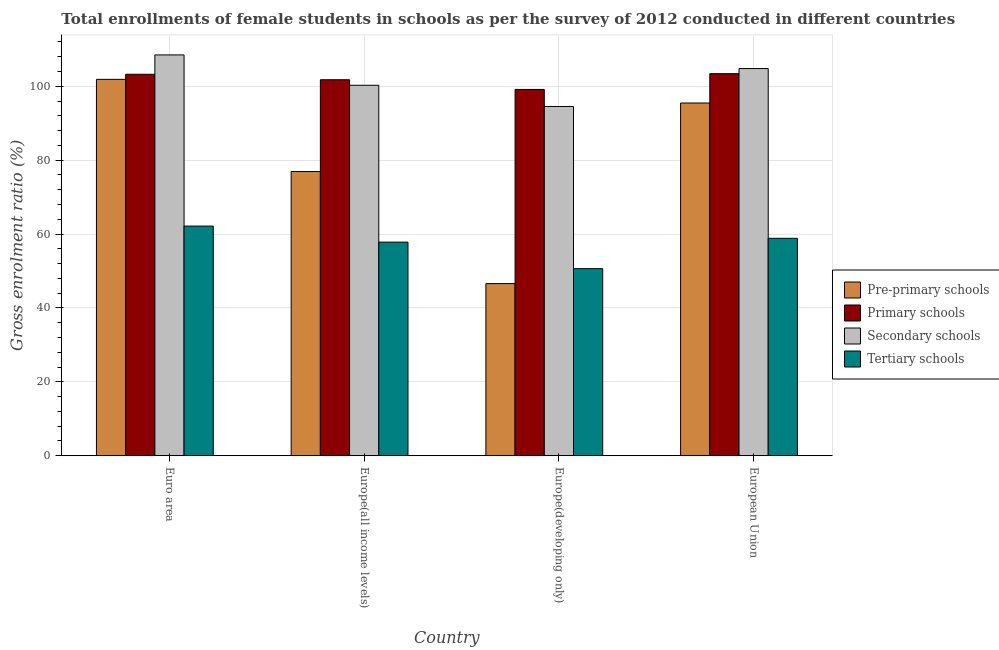Are the number of bars per tick equal to the number of legend labels?
Make the answer very short. Yes. How many bars are there on the 3rd tick from the left?
Ensure brevity in your answer.  4. What is the label of the 2nd group of bars from the left?
Offer a very short reply. Europe(all income levels). In how many cases, is the number of bars for a given country not equal to the number of legend labels?
Give a very brief answer. 0. What is the gross enrolment ratio(female) in primary schools in Europe(all income levels)?
Your response must be concise. 101.75. Across all countries, what is the maximum gross enrolment ratio(female) in pre-primary schools?
Give a very brief answer. 101.86. Across all countries, what is the minimum gross enrolment ratio(female) in tertiary schools?
Your answer should be compact. 50.63. In which country was the gross enrolment ratio(female) in primary schools maximum?
Your answer should be compact. European Union. In which country was the gross enrolment ratio(female) in pre-primary schools minimum?
Your answer should be very brief. Europe(developing only). What is the total gross enrolment ratio(female) in secondary schools in the graph?
Offer a very short reply. 408.02. What is the difference between the gross enrolment ratio(female) in primary schools in Euro area and that in Europe(developing only)?
Provide a succinct answer. 4.11. What is the difference between the gross enrolment ratio(female) in primary schools in Euro area and the gross enrolment ratio(female) in secondary schools in Europe(all income levels)?
Keep it short and to the point. 2.98. What is the average gross enrolment ratio(female) in secondary schools per country?
Provide a succinct answer. 102.01. What is the difference between the gross enrolment ratio(female) in tertiary schools and gross enrolment ratio(female) in pre-primary schools in Euro area?
Provide a succinct answer. -39.71. In how many countries, is the gross enrolment ratio(female) in tertiary schools greater than 84 %?
Give a very brief answer. 0. What is the ratio of the gross enrolment ratio(female) in secondary schools in Europe(all income levels) to that in European Union?
Provide a short and direct response. 0.96. Is the gross enrolment ratio(female) in pre-primary schools in Europe(developing only) less than that in European Union?
Offer a very short reply. Yes. What is the difference between the highest and the second highest gross enrolment ratio(female) in secondary schools?
Provide a succinct answer. 3.69. What is the difference between the highest and the lowest gross enrolment ratio(female) in primary schools?
Your answer should be compact. 4.27. In how many countries, is the gross enrolment ratio(female) in secondary schools greater than the average gross enrolment ratio(female) in secondary schools taken over all countries?
Keep it short and to the point. 2. Is it the case that in every country, the sum of the gross enrolment ratio(female) in tertiary schools and gross enrolment ratio(female) in secondary schools is greater than the sum of gross enrolment ratio(female) in primary schools and gross enrolment ratio(female) in pre-primary schools?
Give a very brief answer. Yes. What does the 3rd bar from the left in Euro area represents?
Keep it short and to the point. Secondary schools. What does the 4th bar from the right in Europe(developing only) represents?
Give a very brief answer. Pre-primary schools. Are all the bars in the graph horizontal?
Your answer should be compact. No. What is the difference between two consecutive major ticks on the Y-axis?
Your answer should be very brief. 20. Does the graph contain any zero values?
Provide a short and direct response. No. How are the legend labels stacked?
Provide a short and direct response. Vertical. What is the title of the graph?
Your response must be concise. Total enrollments of female students in schools as per the survey of 2012 conducted in different countries. What is the label or title of the Y-axis?
Your answer should be compact. Gross enrolment ratio (%). What is the Gross enrolment ratio (%) in Pre-primary schools in Euro area?
Your response must be concise. 101.86. What is the Gross enrolment ratio (%) of Primary schools in Euro area?
Your answer should be compact. 103.23. What is the Gross enrolment ratio (%) in Secondary schools in Euro area?
Provide a short and direct response. 108.47. What is the Gross enrolment ratio (%) in Tertiary schools in Euro area?
Make the answer very short. 62.15. What is the Gross enrolment ratio (%) of Pre-primary schools in Europe(all income levels)?
Keep it short and to the point. 76.91. What is the Gross enrolment ratio (%) of Primary schools in Europe(all income levels)?
Your response must be concise. 101.75. What is the Gross enrolment ratio (%) in Secondary schools in Europe(all income levels)?
Your answer should be very brief. 100.25. What is the Gross enrolment ratio (%) in Tertiary schools in Europe(all income levels)?
Provide a short and direct response. 57.81. What is the Gross enrolment ratio (%) in Pre-primary schools in Europe(developing only)?
Offer a terse response. 46.59. What is the Gross enrolment ratio (%) in Primary schools in Europe(developing only)?
Your answer should be compact. 99.13. What is the Gross enrolment ratio (%) in Secondary schools in Europe(developing only)?
Keep it short and to the point. 94.52. What is the Gross enrolment ratio (%) in Tertiary schools in Europe(developing only)?
Keep it short and to the point. 50.63. What is the Gross enrolment ratio (%) in Pre-primary schools in European Union?
Keep it short and to the point. 95.46. What is the Gross enrolment ratio (%) in Primary schools in European Union?
Your answer should be compact. 103.4. What is the Gross enrolment ratio (%) in Secondary schools in European Union?
Your answer should be very brief. 104.78. What is the Gross enrolment ratio (%) of Tertiary schools in European Union?
Give a very brief answer. 58.84. Across all countries, what is the maximum Gross enrolment ratio (%) in Pre-primary schools?
Your response must be concise. 101.86. Across all countries, what is the maximum Gross enrolment ratio (%) in Primary schools?
Provide a short and direct response. 103.4. Across all countries, what is the maximum Gross enrolment ratio (%) in Secondary schools?
Ensure brevity in your answer.  108.47. Across all countries, what is the maximum Gross enrolment ratio (%) in Tertiary schools?
Give a very brief answer. 62.15. Across all countries, what is the minimum Gross enrolment ratio (%) in Pre-primary schools?
Ensure brevity in your answer.  46.59. Across all countries, what is the minimum Gross enrolment ratio (%) in Primary schools?
Offer a terse response. 99.13. Across all countries, what is the minimum Gross enrolment ratio (%) in Secondary schools?
Your response must be concise. 94.52. Across all countries, what is the minimum Gross enrolment ratio (%) of Tertiary schools?
Keep it short and to the point. 50.63. What is the total Gross enrolment ratio (%) of Pre-primary schools in the graph?
Your answer should be very brief. 320.82. What is the total Gross enrolment ratio (%) of Primary schools in the graph?
Offer a very short reply. 407.51. What is the total Gross enrolment ratio (%) in Secondary schools in the graph?
Your response must be concise. 408.02. What is the total Gross enrolment ratio (%) of Tertiary schools in the graph?
Give a very brief answer. 229.43. What is the difference between the Gross enrolment ratio (%) in Pre-primary schools in Euro area and that in Europe(all income levels)?
Provide a succinct answer. 24.95. What is the difference between the Gross enrolment ratio (%) of Primary schools in Euro area and that in Europe(all income levels)?
Your answer should be very brief. 1.48. What is the difference between the Gross enrolment ratio (%) in Secondary schools in Euro area and that in Europe(all income levels)?
Provide a short and direct response. 8.22. What is the difference between the Gross enrolment ratio (%) of Tertiary schools in Euro area and that in Europe(all income levels)?
Make the answer very short. 4.34. What is the difference between the Gross enrolment ratio (%) of Pre-primary schools in Euro area and that in Europe(developing only)?
Keep it short and to the point. 55.28. What is the difference between the Gross enrolment ratio (%) in Primary schools in Euro area and that in Europe(developing only)?
Offer a very short reply. 4.11. What is the difference between the Gross enrolment ratio (%) in Secondary schools in Euro area and that in Europe(developing only)?
Your response must be concise. 13.96. What is the difference between the Gross enrolment ratio (%) of Tertiary schools in Euro area and that in Europe(developing only)?
Offer a terse response. 11.52. What is the difference between the Gross enrolment ratio (%) in Pre-primary schools in Euro area and that in European Union?
Your answer should be very brief. 6.4. What is the difference between the Gross enrolment ratio (%) of Primary schools in Euro area and that in European Union?
Your answer should be compact. -0.16. What is the difference between the Gross enrolment ratio (%) of Secondary schools in Euro area and that in European Union?
Make the answer very short. 3.69. What is the difference between the Gross enrolment ratio (%) in Tertiary schools in Euro area and that in European Union?
Ensure brevity in your answer.  3.31. What is the difference between the Gross enrolment ratio (%) in Pre-primary schools in Europe(all income levels) and that in Europe(developing only)?
Make the answer very short. 30.33. What is the difference between the Gross enrolment ratio (%) in Primary schools in Europe(all income levels) and that in Europe(developing only)?
Offer a very short reply. 2.62. What is the difference between the Gross enrolment ratio (%) in Secondary schools in Europe(all income levels) and that in Europe(developing only)?
Provide a short and direct response. 5.74. What is the difference between the Gross enrolment ratio (%) in Tertiary schools in Europe(all income levels) and that in Europe(developing only)?
Provide a succinct answer. 7.18. What is the difference between the Gross enrolment ratio (%) of Pre-primary schools in Europe(all income levels) and that in European Union?
Keep it short and to the point. -18.54. What is the difference between the Gross enrolment ratio (%) in Primary schools in Europe(all income levels) and that in European Union?
Offer a terse response. -1.64. What is the difference between the Gross enrolment ratio (%) of Secondary schools in Europe(all income levels) and that in European Union?
Your answer should be very brief. -4.53. What is the difference between the Gross enrolment ratio (%) in Tertiary schools in Europe(all income levels) and that in European Union?
Provide a short and direct response. -1.03. What is the difference between the Gross enrolment ratio (%) in Pre-primary schools in Europe(developing only) and that in European Union?
Provide a succinct answer. -48.87. What is the difference between the Gross enrolment ratio (%) of Primary schools in Europe(developing only) and that in European Union?
Offer a terse response. -4.27. What is the difference between the Gross enrolment ratio (%) in Secondary schools in Europe(developing only) and that in European Union?
Give a very brief answer. -10.27. What is the difference between the Gross enrolment ratio (%) of Tertiary schools in Europe(developing only) and that in European Union?
Provide a short and direct response. -8.21. What is the difference between the Gross enrolment ratio (%) of Pre-primary schools in Euro area and the Gross enrolment ratio (%) of Primary schools in Europe(all income levels)?
Provide a short and direct response. 0.11. What is the difference between the Gross enrolment ratio (%) of Pre-primary schools in Euro area and the Gross enrolment ratio (%) of Secondary schools in Europe(all income levels)?
Your answer should be compact. 1.61. What is the difference between the Gross enrolment ratio (%) in Pre-primary schools in Euro area and the Gross enrolment ratio (%) in Tertiary schools in Europe(all income levels)?
Give a very brief answer. 44.06. What is the difference between the Gross enrolment ratio (%) in Primary schools in Euro area and the Gross enrolment ratio (%) in Secondary schools in Europe(all income levels)?
Your answer should be very brief. 2.98. What is the difference between the Gross enrolment ratio (%) in Primary schools in Euro area and the Gross enrolment ratio (%) in Tertiary schools in Europe(all income levels)?
Keep it short and to the point. 45.43. What is the difference between the Gross enrolment ratio (%) of Secondary schools in Euro area and the Gross enrolment ratio (%) of Tertiary schools in Europe(all income levels)?
Offer a terse response. 50.67. What is the difference between the Gross enrolment ratio (%) of Pre-primary schools in Euro area and the Gross enrolment ratio (%) of Primary schools in Europe(developing only)?
Make the answer very short. 2.73. What is the difference between the Gross enrolment ratio (%) in Pre-primary schools in Euro area and the Gross enrolment ratio (%) in Secondary schools in Europe(developing only)?
Provide a succinct answer. 7.35. What is the difference between the Gross enrolment ratio (%) of Pre-primary schools in Euro area and the Gross enrolment ratio (%) of Tertiary schools in Europe(developing only)?
Offer a very short reply. 51.23. What is the difference between the Gross enrolment ratio (%) in Primary schools in Euro area and the Gross enrolment ratio (%) in Secondary schools in Europe(developing only)?
Give a very brief answer. 8.72. What is the difference between the Gross enrolment ratio (%) in Primary schools in Euro area and the Gross enrolment ratio (%) in Tertiary schools in Europe(developing only)?
Your response must be concise. 52.6. What is the difference between the Gross enrolment ratio (%) in Secondary schools in Euro area and the Gross enrolment ratio (%) in Tertiary schools in Europe(developing only)?
Offer a very short reply. 57.84. What is the difference between the Gross enrolment ratio (%) in Pre-primary schools in Euro area and the Gross enrolment ratio (%) in Primary schools in European Union?
Offer a very short reply. -1.54. What is the difference between the Gross enrolment ratio (%) of Pre-primary schools in Euro area and the Gross enrolment ratio (%) of Secondary schools in European Union?
Keep it short and to the point. -2.92. What is the difference between the Gross enrolment ratio (%) in Pre-primary schools in Euro area and the Gross enrolment ratio (%) in Tertiary schools in European Union?
Your response must be concise. 43.02. What is the difference between the Gross enrolment ratio (%) in Primary schools in Euro area and the Gross enrolment ratio (%) in Secondary schools in European Union?
Make the answer very short. -1.55. What is the difference between the Gross enrolment ratio (%) in Primary schools in Euro area and the Gross enrolment ratio (%) in Tertiary schools in European Union?
Provide a succinct answer. 44.4. What is the difference between the Gross enrolment ratio (%) of Secondary schools in Euro area and the Gross enrolment ratio (%) of Tertiary schools in European Union?
Your response must be concise. 49.63. What is the difference between the Gross enrolment ratio (%) of Pre-primary schools in Europe(all income levels) and the Gross enrolment ratio (%) of Primary schools in Europe(developing only)?
Provide a short and direct response. -22.22. What is the difference between the Gross enrolment ratio (%) of Pre-primary schools in Europe(all income levels) and the Gross enrolment ratio (%) of Secondary schools in Europe(developing only)?
Your response must be concise. -17.6. What is the difference between the Gross enrolment ratio (%) in Pre-primary schools in Europe(all income levels) and the Gross enrolment ratio (%) in Tertiary schools in Europe(developing only)?
Make the answer very short. 26.28. What is the difference between the Gross enrolment ratio (%) of Primary schools in Europe(all income levels) and the Gross enrolment ratio (%) of Secondary schools in Europe(developing only)?
Provide a short and direct response. 7.24. What is the difference between the Gross enrolment ratio (%) in Primary schools in Europe(all income levels) and the Gross enrolment ratio (%) in Tertiary schools in Europe(developing only)?
Provide a short and direct response. 51.12. What is the difference between the Gross enrolment ratio (%) of Secondary schools in Europe(all income levels) and the Gross enrolment ratio (%) of Tertiary schools in Europe(developing only)?
Your response must be concise. 49.62. What is the difference between the Gross enrolment ratio (%) of Pre-primary schools in Europe(all income levels) and the Gross enrolment ratio (%) of Primary schools in European Union?
Give a very brief answer. -26.48. What is the difference between the Gross enrolment ratio (%) in Pre-primary schools in Europe(all income levels) and the Gross enrolment ratio (%) in Secondary schools in European Union?
Make the answer very short. -27.87. What is the difference between the Gross enrolment ratio (%) of Pre-primary schools in Europe(all income levels) and the Gross enrolment ratio (%) of Tertiary schools in European Union?
Ensure brevity in your answer.  18.08. What is the difference between the Gross enrolment ratio (%) of Primary schools in Europe(all income levels) and the Gross enrolment ratio (%) of Secondary schools in European Union?
Provide a succinct answer. -3.03. What is the difference between the Gross enrolment ratio (%) of Primary schools in Europe(all income levels) and the Gross enrolment ratio (%) of Tertiary schools in European Union?
Give a very brief answer. 42.91. What is the difference between the Gross enrolment ratio (%) in Secondary schools in Europe(all income levels) and the Gross enrolment ratio (%) in Tertiary schools in European Union?
Keep it short and to the point. 41.42. What is the difference between the Gross enrolment ratio (%) of Pre-primary schools in Europe(developing only) and the Gross enrolment ratio (%) of Primary schools in European Union?
Ensure brevity in your answer.  -56.81. What is the difference between the Gross enrolment ratio (%) of Pre-primary schools in Europe(developing only) and the Gross enrolment ratio (%) of Secondary schools in European Union?
Ensure brevity in your answer.  -58.2. What is the difference between the Gross enrolment ratio (%) of Pre-primary schools in Europe(developing only) and the Gross enrolment ratio (%) of Tertiary schools in European Union?
Ensure brevity in your answer.  -12.25. What is the difference between the Gross enrolment ratio (%) of Primary schools in Europe(developing only) and the Gross enrolment ratio (%) of Secondary schools in European Union?
Ensure brevity in your answer.  -5.65. What is the difference between the Gross enrolment ratio (%) of Primary schools in Europe(developing only) and the Gross enrolment ratio (%) of Tertiary schools in European Union?
Your answer should be very brief. 40.29. What is the difference between the Gross enrolment ratio (%) in Secondary schools in Europe(developing only) and the Gross enrolment ratio (%) in Tertiary schools in European Union?
Provide a succinct answer. 35.68. What is the average Gross enrolment ratio (%) in Pre-primary schools per country?
Your answer should be very brief. 80.2. What is the average Gross enrolment ratio (%) in Primary schools per country?
Your response must be concise. 101.88. What is the average Gross enrolment ratio (%) of Secondary schools per country?
Your answer should be compact. 102.01. What is the average Gross enrolment ratio (%) in Tertiary schools per country?
Your response must be concise. 57.36. What is the difference between the Gross enrolment ratio (%) of Pre-primary schools and Gross enrolment ratio (%) of Primary schools in Euro area?
Offer a very short reply. -1.37. What is the difference between the Gross enrolment ratio (%) in Pre-primary schools and Gross enrolment ratio (%) in Secondary schools in Euro area?
Provide a succinct answer. -6.61. What is the difference between the Gross enrolment ratio (%) of Pre-primary schools and Gross enrolment ratio (%) of Tertiary schools in Euro area?
Your answer should be very brief. 39.71. What is the difference between the Gross enrolment ratio (%) of Primary schools and Gross enrolment ratio (%) of Secondary schools in Euro area?
Your answer should be compact. -5.24. What is the difference between the Gross enrolment ratio (%) in Primary schools and Gross enrolment ratio (%) in Tertiary schools in Euro area?
Offer a terse response. 41.08. What is the difference between the Gross enrolment ratio (%) of Secondary schools and Gross enrolment ratio (%) of Tertiary schools in Euro area?
Offer a very short reply. 46.32. What is the difference between the Gross enrolment ratio (%) in Pre-primary schools and Gross enrolment ratio (%) in Primary schools in Europe(all income levels)?
Your answer should be compact. -24.84. What is the difference between the Gross enrolment ratio (%) of Pre-primary schools and Gross enrolment ratio (%) of Secondary schools in Europe(all income levels)?
Ensure brevity in your answer.  -23.34. What is the difference between the Gross enrolment ratio (%) in Pre-primary schools and Gross enrolment ratio (%) in Tertiary schools in Europe(all income levels)?
Keep it short and to the point. 19.11. What is the difference between the Gross enrolment ratio (%) of Primary schools and Gross enrolment ratio (%) of Secondary schools in Europe(all income levels)?
Give a very brief answer. 1.5. What is the difference between the Gross enrolment ratio (%) of Primary schools and Gross enrolment ratio (%) of Tertiary schools in Europe(all income levels)?
Keep it short and to the point. 43.95. What is the difference between the Gross enrolment ratio (%) of Secondary schools and Gross enrolment ratio (%) of Tertiary schools in Europe(all income levels)?
Your answer should be very brief. 42.45. What is the difference between the Gross enrolment ratio (%) in Pre-primary schools and Gross enrolment ratio (%) in Primary schools in Europe(developing only)?
Provide a short and direct response. -52.54. What is the difference between the Gross enrolment ratio (%) of Pre-primary schools and Gross enrolment ratio (%) of Secondary schools in Europe(developing only)?
Your answer should be very brief. -47.93. What is the difference between the Gross enrolment ratio (%) in Pre-primary schools and Gross enrolment ratio (%) in Tertiary schools in Europe(developing only)?
Make the answer very short. -4.05. What is the difference between the Gross enrolment ratio (%) of Primary schools and Gross enrolment ratio (%) of Secondary schools in Europe(developing only)?
Your answer should be compact. 4.61. What is the difference between the Gross enrolment ratio (%) in Primary schools and Gross enrolment ratio (%) in Tertiary schools in Europe(developing only)?
Keep it short and to the point. 48.5. What is the difference between the Gross enrolment ratio (%) of Secondary schools and Gross enrolment ratio (%) of Tertiary schools in Europe(developing only)?
Keep it short and to the point. 43.88. What is the difference between the Gross enrolment ratio (%) of Pre-primary schools and Gross enrolment ratio (%) of Primary schools in European Union?
Offer a terse response. -7.94. What is the difference between the Gross enrolment ratio (%) in Pre-primary schools and Gross enrolment ratio (%) in Secondary schools in European Union?
Give a very brief answer. -9.32. What is the difference between the Gross enrolment ratio (%) of Pre-primary schools and Gross enrolment ratio (%) of Tertiary schools in European Union?
Your response must be concise. 36.62. What is the difference between the Gross enrolment ratio (%) of Primary schools and Gross enrolment ratio (%) of Secondary schools in European Union?
Give a very brief answer. -1.38. What is the difference between the Gross enrolment ratio (%) in Primary schools and Gross enrolment ratio (%) in Tertiary schools in European Union?
Keep it short and to the point. 44.56. What is the difference between the Gross enrolment ratio (%) of Secondary schools and Gross enrolment ratio (%) of Tertiary schools in European Union?
Offer a very short reply. 45.94. What is the ratio of the Gross enrolment ratio (%) in Pre-primary schools in Euro area to that in Europe(all income levels)?
Offer a very short reply. 1.32. What is the ratio of the Gross enrolment ratio (%) in Primary schools in Euro area to that in Europe(all income levels)?
Give a very brief answer. 1.01. What is the ratio of the Gross enrolment ratio (%) of Secondary schools in Euro area to that in Europe(all income levels)?
Give a very brief answer. 1.08. What is the ratio of the Gross enrolment ratio (%) of Tertiary schools in Euro area to that in Europe(all income levels)?
Offer a very short reply. 1.08. What is the ratio of the Gross enrolment ratio (%) of Pre-primary schools in Euro area to that in Europe(developing only)?
Offer a very short reply. 2.19. What is the ratio of the Gross enrolment ratio (%) in Primary schools in Euro area to that in Europe(developing only)?
Provide a short and direct response. 1.04. What is the ratio of the Gross enrolment ratio (%) in Secondary schools in Euro area to that in Europe(developing only)?
Ensure brevity in your answer.  1.15. What is the ratio of the Gross enrolment ratio (%) of Tertiary schools in Euro area to that in Europe(developing only)?
Offer a terse response. 1.23. What is the ratio of the Gross enrolment ratio (%) of Pre-primary schools in Euro area to that in European Union?
Provide a succinct answer. 1.07. What is the ratio of the Gross enrolment ratio (%) in Primary schools in Euro area to that in European Union?
Keep it short and to the point. 1. What is the ratio of the Gross enrolment ratio (%) in Secondary schools in Euro area to that in European Union?
Your answer should be compact. 1.04. What is the ratio of the Gross enrolment ratio (%) of Tertiary schools in Euro area to that in European Union?
Offer a terse response. 1.06. What is the ratio of the Gross enrolment ratio (%) in Pre-primary schools in Europe(all income levels) to that in Europe(developing only)?
Keep it short and to the point. 1.65. What is the ratio of the Gross enrolment ratio (%) of Primary schools in Europe(all income levels) to that in Europe(developing only)?
Your answer should be very brief. 1.03. What is the ratio of the Gross enrolment ratio (%) in Secondary schools in Europe(all income levels) to that in Europe(developing only)?
Give a very brief answer. 1.06. What is the ratio of the Gross enrolment ratio (%) in Tertiary schools in Europe(all income levels) to that in Europe(developing only)?
Your answer should be compact. 1.14. What is the ratio of the Gross enrolment ratio (%) in Pre-primary schools in Europe(all income levels) to that in European Union?
Offer a very short reply. 0.81. What is the ratio of the Gross enrolment ratio (%) of Primary schools in Europe(all income levels) to that in European Union?
Offer a very short reply. 0.98. What is the ratio of the Gross enrolment ratio (%) of Secondary schools in Europe(all income levels) to that in European Union?
Make the answer very short. 0.96. What is the ratio of the Gross enrolment ratio (%) of Tertiary schools in Europe(all income levels) to that in European Union?
Provide a succinct answer. 0.98. What is the ratio of the Gross enrolment ratio (%) in Pre-primary schools in Europe(developing only) to that in European Union?
Ensure brevity in your answer.  0.49. What is the ratio of the Gross enrolment ratio (%) of Primary schools in Europe(developing only) to that in European Union?
Give a very brief answer. 0.96. What is the ratio of the Gross enrolment ratio (%) in Secondary schools in Europe(developing only) to that in European Union?
Offer a terse response. 0.9. What is the ratio of the Gross enrolment ratio (%) in Tertiary schools in Europe(developing only) to that in European Union?
Your response must be concise. 0.86. What is the difference between the highest and the second highest Gross enrolment ratio (%) in Pre-primary schools?
Provide a succinct answer. 6.4. What is the difference between the highest and the second highest Gross enrolment ratio (%) in Primary schools?
Ensure brevity in your answer.  0.16. What is the difference between the highest and the second highest Gross enrolment ratio (%) in Secondary schools?
Offer a very short reply. 3.69. What is the difference between the highest and the second highest Gross enrolment ratio (%) in Tertiary schools?
Your response must be concise. 3.31. What is the difference between the highest and the lowest Gross enrolment ratio (%) in Pre-primary schools?
Provide a short and direct response. 55.28. What is the difference between the highest and the lowest Gross enrolment ratio (%) in Primary schools?
Your answer should be very brief. 4.27. What is the difference between the highest and the lowest Gross enrolment ratio (%) of Secondary schools?
Offer a very short reply. 13.96. What is the difference between the highest and the lowest Gross enrolment ratio (%) in Tertiary schools?
Give a very brief answer. 11.52. 